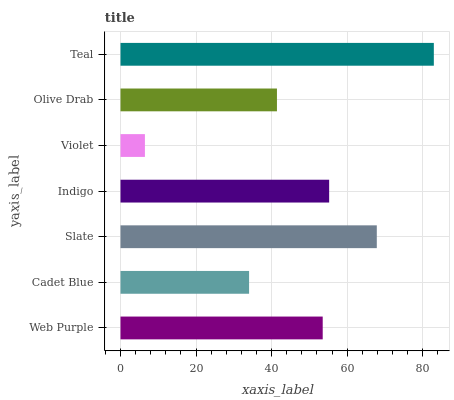Is Violet the minimum?
Answer yes or no. Yes. Is Teal the maximum?
Answer yes or no. Yes. Is Cadet Blue the minimum?
Answer yes or no. No. Is Cadet Blue the maximum?
Answer yes or no. No. Is Web Purple greater than Cadet Blue?
Answer yes or no. Yes. Is Cadet Blue less than Web Purple?
Answer yes or no. Yes. Is Cadet Blue greater than Web Purple?
Answer yes or no. No. Is Web Purple less than Cadet Blue?
Answer yes or no. No. Is Web Purple the high median?
Answer yes or no. Yes. Is Web Purple the low median?
Answer yes or no. Yes. Is Cadet Blue the high median?
Answer yes or no. No. Is Cadet Blue the low median?
Answer yes or no. No. 